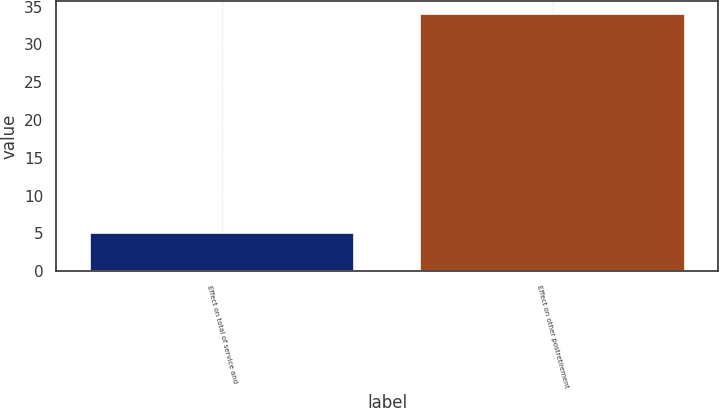Convert chart. <chart><loc_0><loc_0><loc_500><loc_500><bar_chart><fcel>Effect on total of service and<fcel>Effect on other postretirement<nl><fcel>5<fcel>34<nl></chart> 